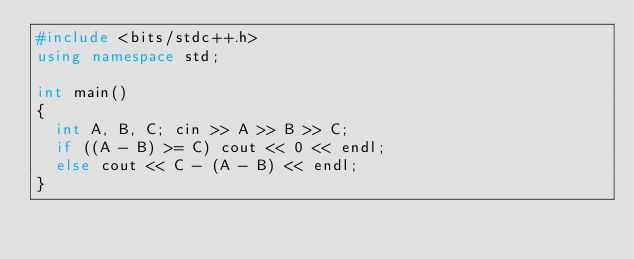<code> <loc_0><loc_0><loc_500><loc_500><_C++_>#include <bits/stdc++.h>
using namespace std;

int main()
{
  int A, B, C; cin >> A >> B >> C;
  if ((A - B) >= C) cout << 0 << endl;
  else cout << C - (A - B) << endl;
}</code> 